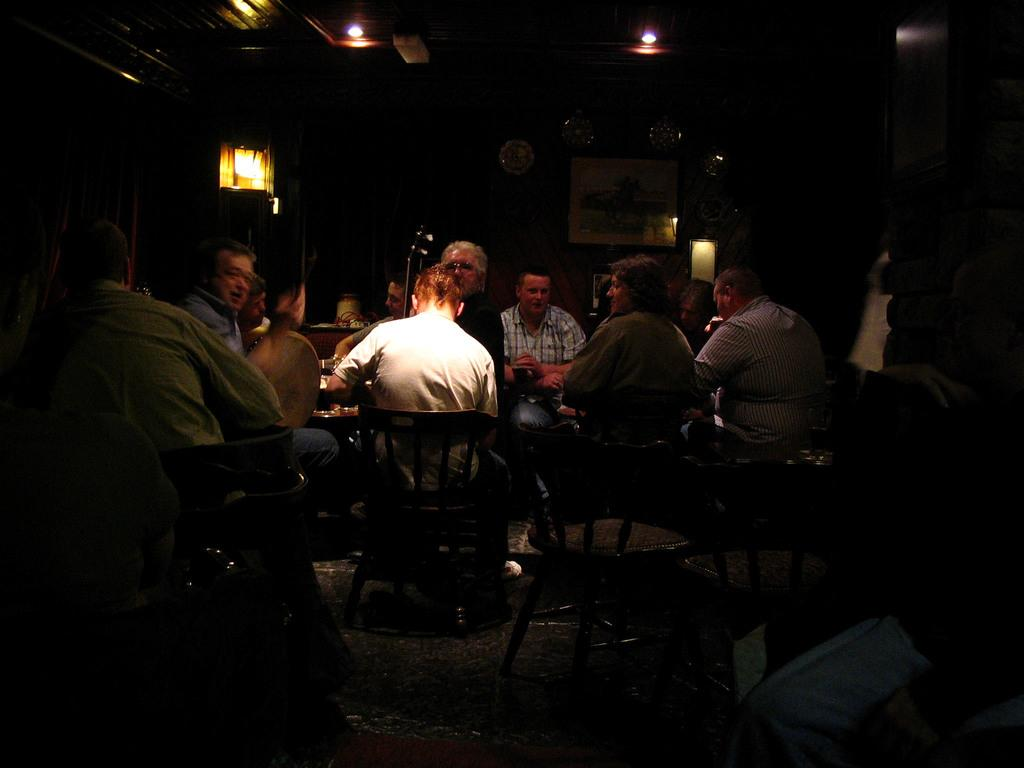What are the people in the image doing? There are many people sitting on chairs in the image. What can be seen in the background of the image? There are lights visible in the background of the image. Can you describe any specific object in the image? There is a photo frame in the image. What other objects can be seen in the image? There are other objects present in the image. What type of yam is being used to treat the wound in the image? There is no yam or wound present in the image; it features people sitting on chairs with a photo frame and other unspecified objects. 